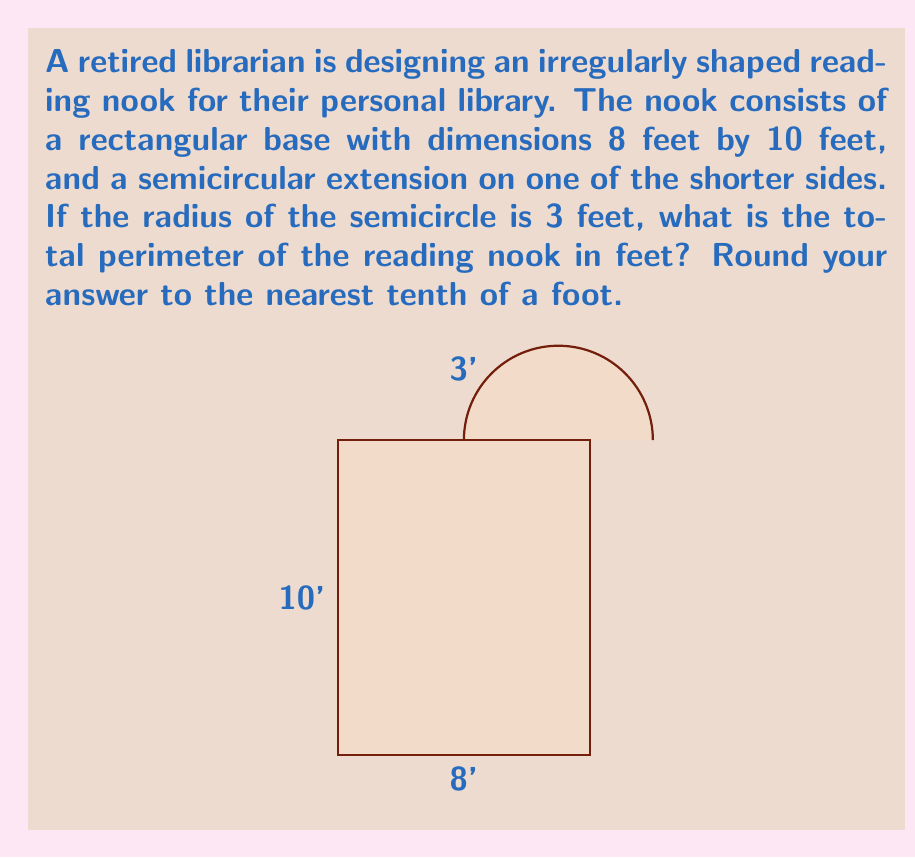Provide a solution to this math problem. Let's approach this step-by-step:

1) First, let's identify the components of the perimeter:
   - Two long sides of the rectangle
   - One short side of the rectangle
   - The semicircular arc

2) The long sides of the rectangle:
   $2 * 10 = 20$ feet

3) The short side of the rectangle (the one without the semicircle):
   $8$ feet

4) For the semicircular arc, we need to calculate its length:
   - The formula for the length of a semicircle is $\pi r$
   - Here, $r = 3$ feet
   - So, the length of the arc is $\pi * 3$ feet

5) Now, let's add all these components:
   $$\text{Perimeter} = 20 + 8 + 3\pi$$

6) Let's calculate:
   $$\begin{align}
   \text{Perimeter} &= 20 + 8 + 3\pi \\
                    &= 28 + 3\pi \\
                    &= 28 + 3 * 3.14159... \\
                    &= 28 + 9.42477... \\
                    &= 37.42477...
   \end{align}$$

7) Rounding to the nearest tenth:
   $37.4$ feet
Answer: $37.4$ feet 